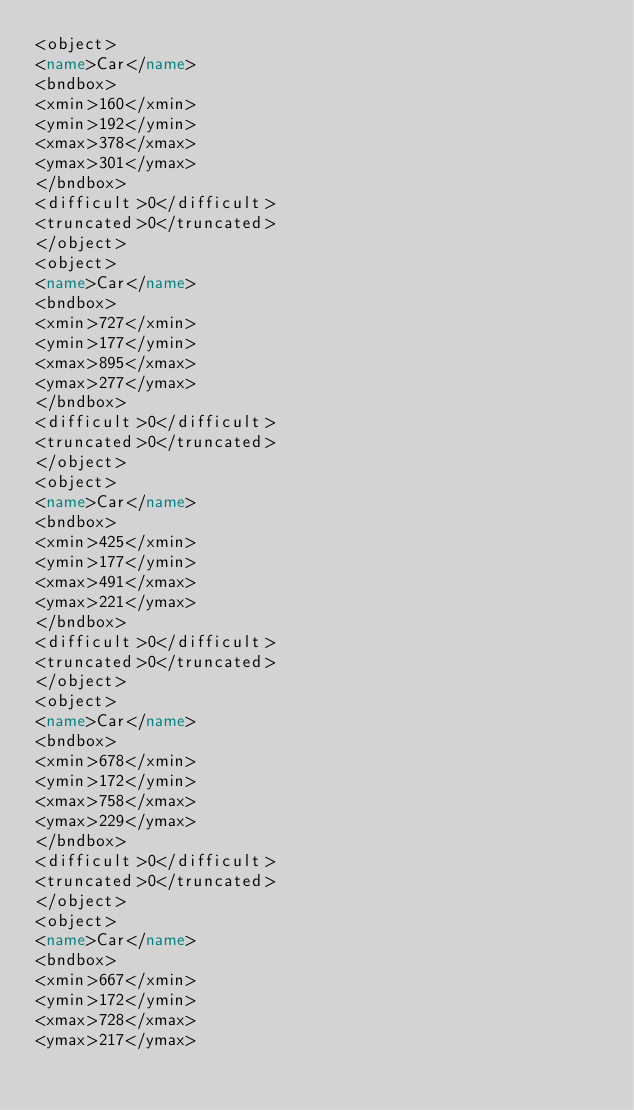<code> <loc_0><loc_0><loc_500><loc_500><_XML_><object>
<name>Car</name>
<bndbox>
<xmin>160</xmin>
<ymin>192</ymin>
<xmax>378</xmax>
<ymax>301</ymax>
</bndbox>
<difficult>0</difficult>
<truncated>0</truncated>
</object>
<object>
<name>Car</name>
<bndbox>
<xmin>727</xmin>
<ymin>177</ymin>
<xmax>895</xmax>
<ymax>277</ymax>
</bndbox>
<difficult>0</difficult>
<truncated>0</truncated>
</object>
<object>
<name>Car</name>
<bndbox>
<xmin>425</xmin>
<ymin>177</ymin>
<xmax>491</xmax>
<ymax>221</ymax>
</bndbox>
<difficult>0</difficult>
<truncated>0</truncated>
</object>
<object>
<name>Car</name>
<bndbox>
<xmin>678</xmin>
<ymin>172</ymin>
<xmax>758</xmax>
<ymax>229</ymax>
</bndbox>
<difficult>0</difficult>
<truncated>0</truncated>
</object>
<object>
<name>Car</name>
<bndbox>
<xmin>667</xmin>
<ymin>172</ymin>
<xmax>728</xmax>
<ymax>217</ymax></code> 